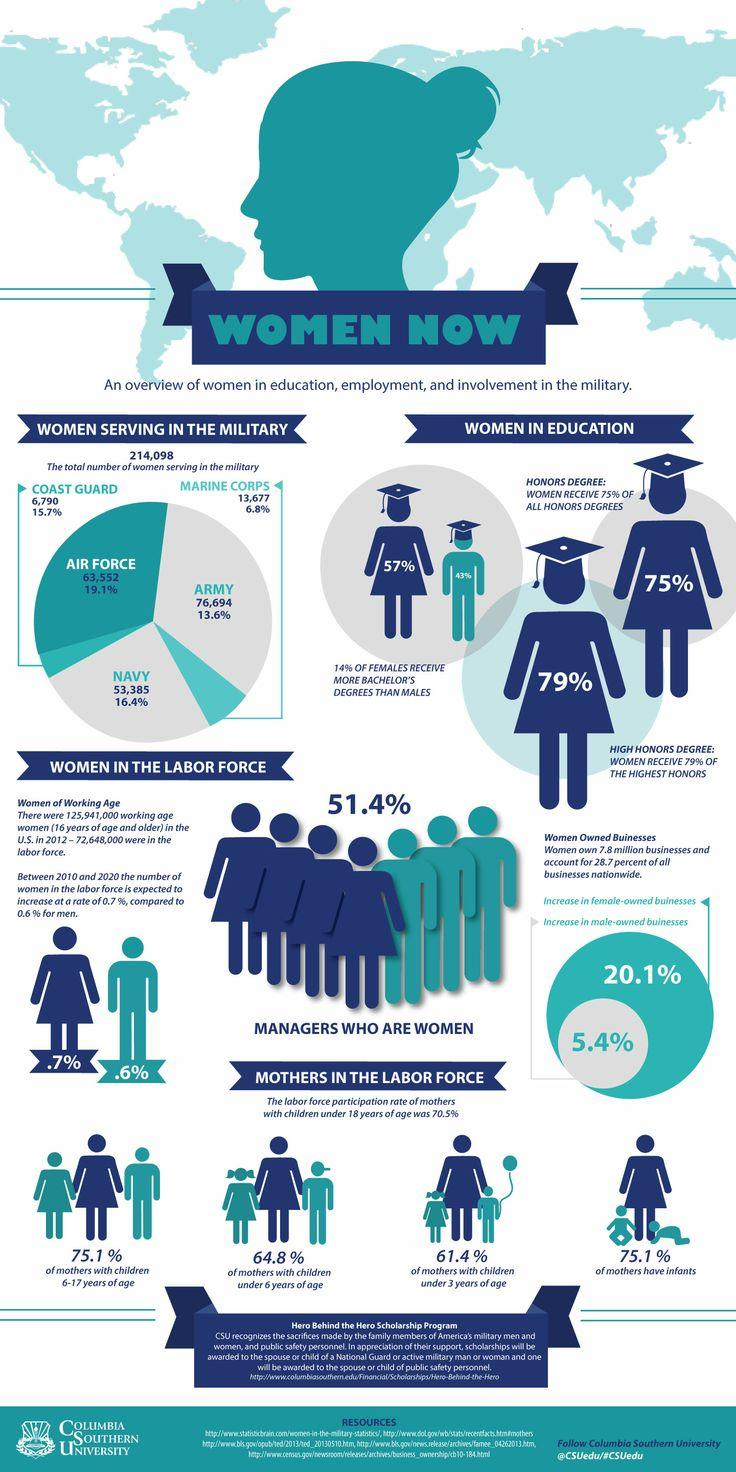Highlight a few significant elements in this photo. In the United States, approximately 51.4% of women hold managerial positions. According to data from the U.S. Navy, 16.4% of its services are comprised of women. In the United States, 75.1% of mothers of infants are part of the labor force. As of 2021, the total number of women serving in the U.S. Air Force is 63,552. The percentage increase in female-owned businesses in the U.S. was 20.1%. 